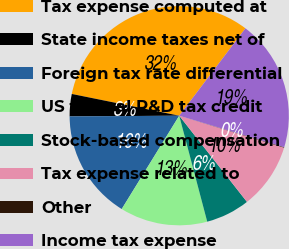Convert chart to OTSL. <chart><loc_0><loc_0><loc_500><loc_500><pie_chart><fcel>Tax expense computed at<fcel>State income taxes net of<fcel>Foreign tax rate differential<fcel>US federal R&D tax credit<fcel>Stock-based compensation<fcel>Tax expense related to<fcel>Other<fcel>Income tax expense<nl><fcel>32.14%<fcel>3.28%<fcel>16.11%<fcel>12.9%<fcel>6.49%<fcel>9.69%<fcel>0.08%<fcel>19.31%<nl></chart> 